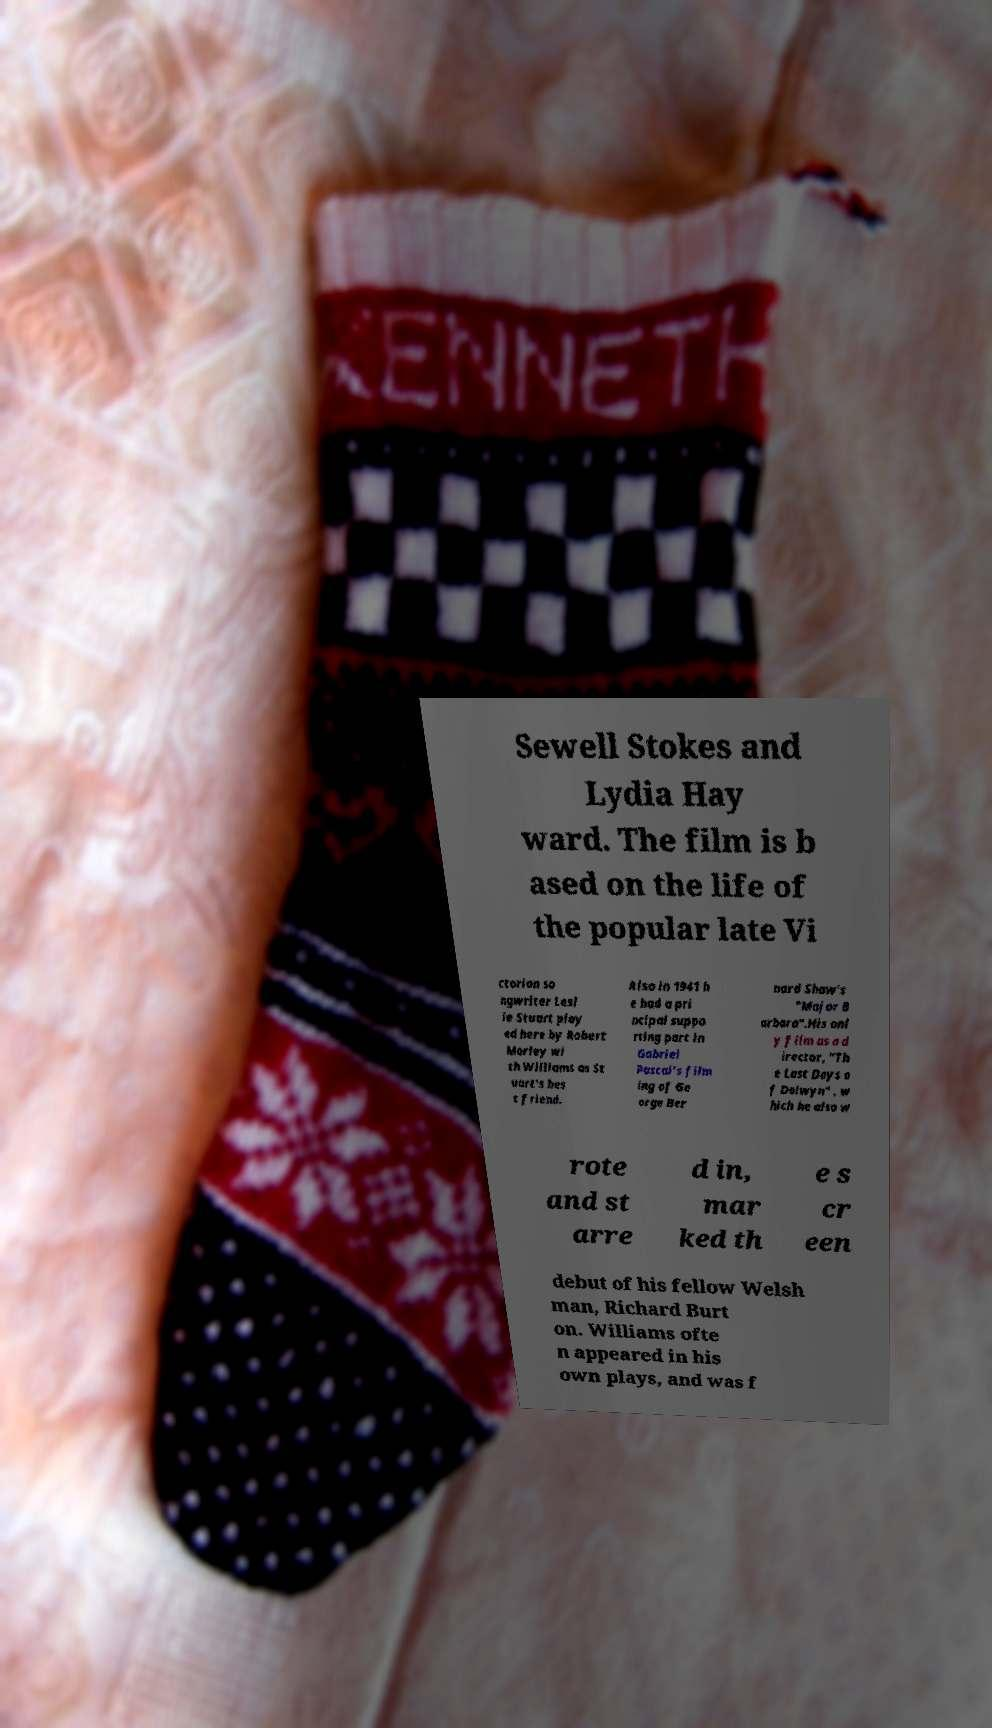Please read and relay the text visible in this image. What does it say? Sewell Stokes and Lydia Hay ward. The film is b ased on the life of the popular late Vi ctorian so ngwriter Lesl ie Stuart play ed here by Robert Morley wi th Williams as St uart's bes t friend. Also in 1941 h e had a pri ncipal suppo rting part in Gabriel Pascal's film ing of Ge orge Ber nard Shaw's "Major B arbara".His onl y film as a d irector, "Th e Last Days o f Dolwyn" , w hich he also w rote and st arre d in, mar ked th e s cr een debut of his fellow Welsh man, Richard Burt on. Williams ofte n appeared in his own plays, and was f 